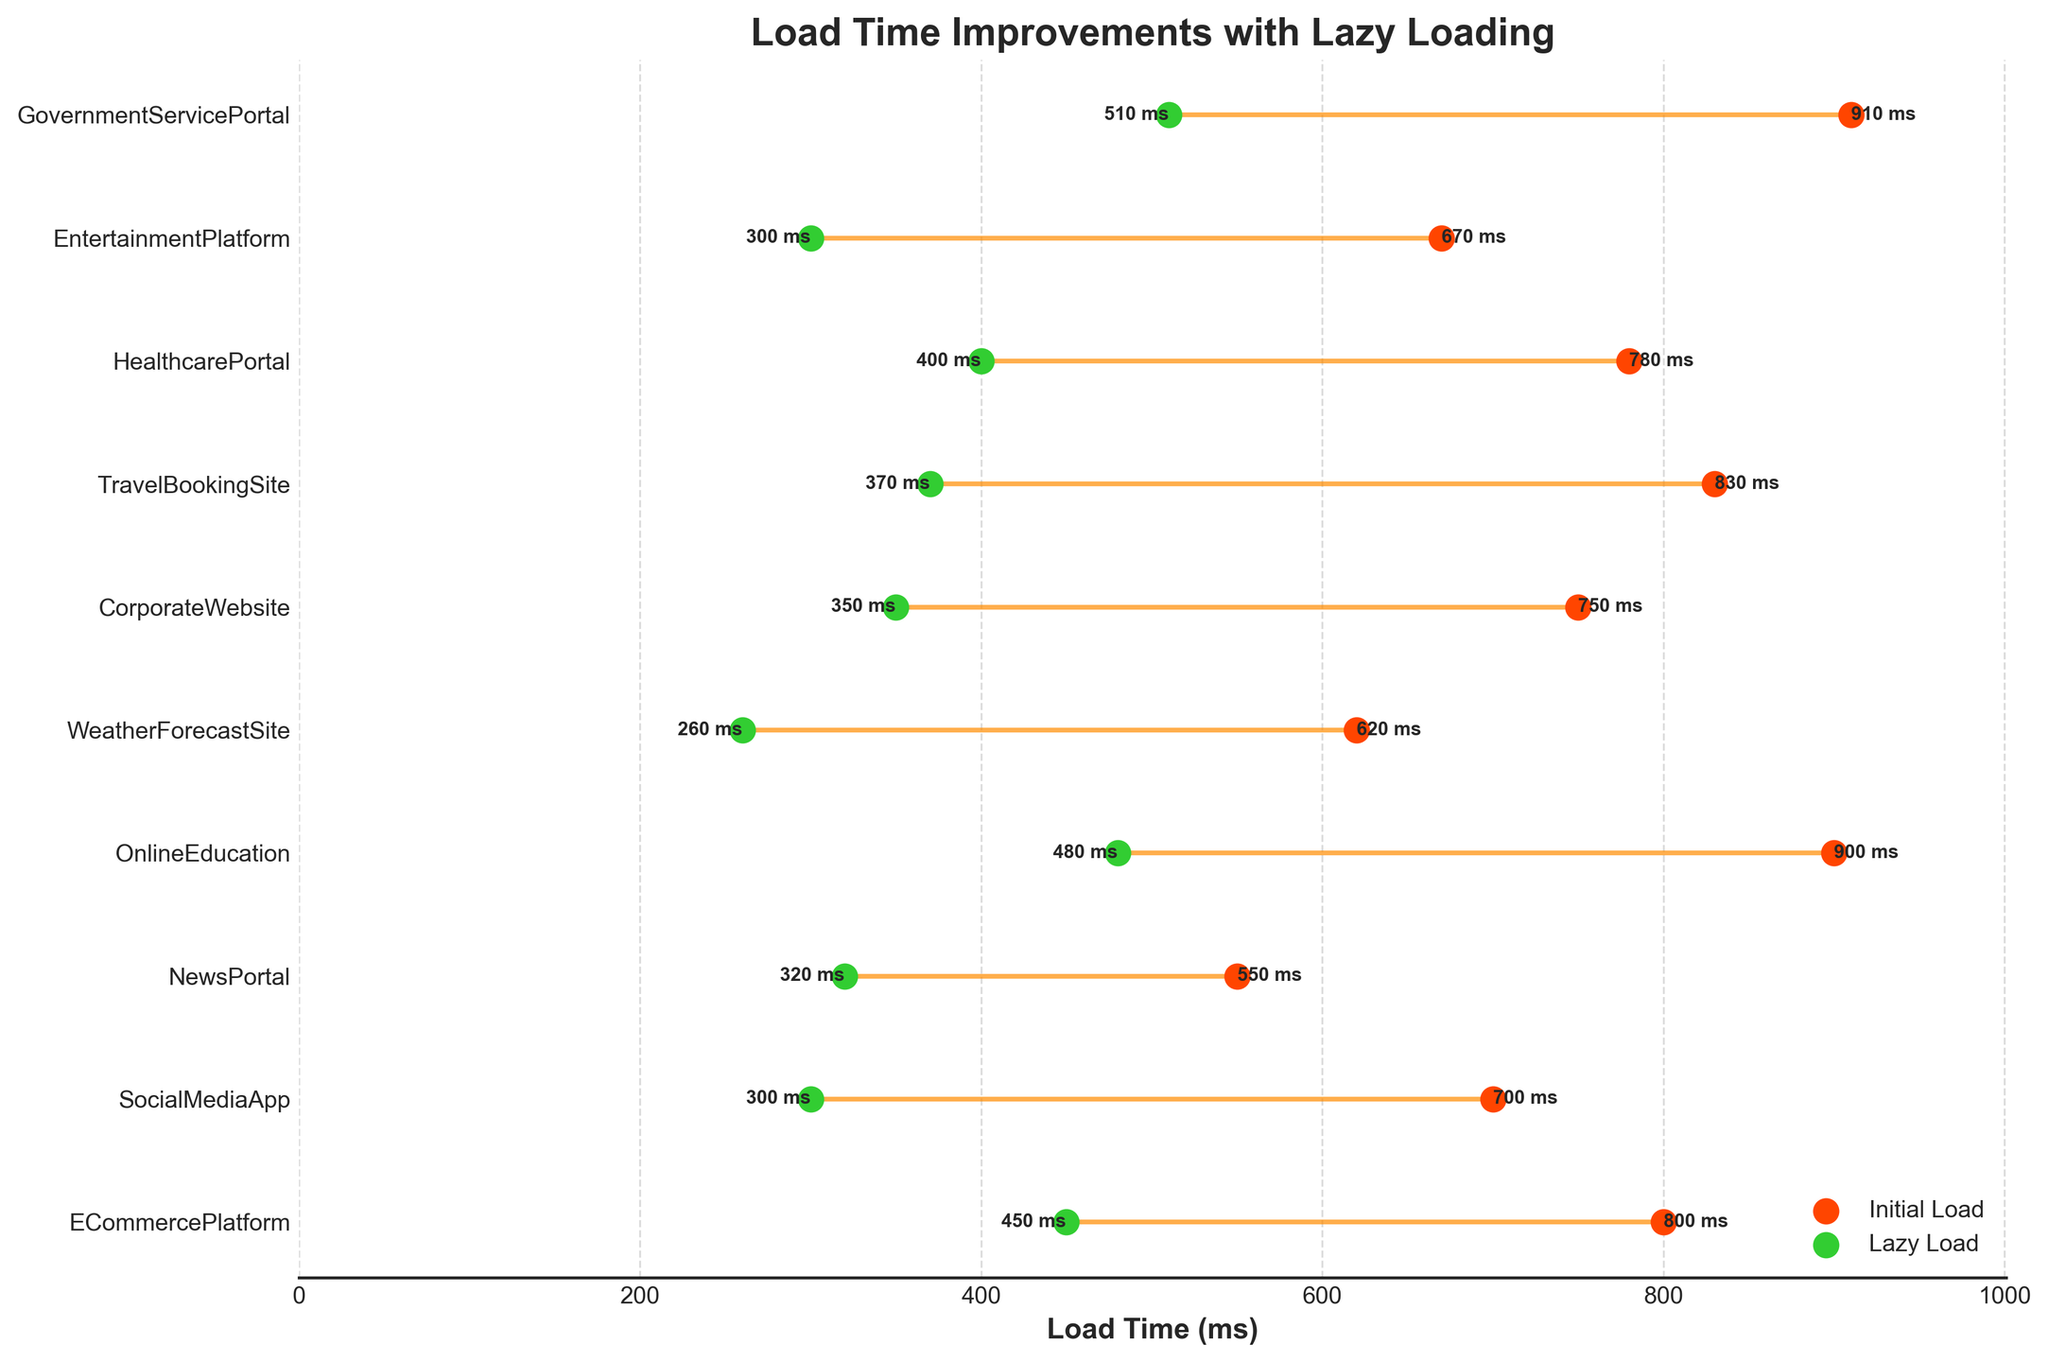What is the title of the chart? The title is displayed at the top of the chart.
Answer: Load Time Improvements with Lazy Loading How many applications are displayed in the chart? Count the number of distinct y-axis labels.
Answer: 10 Which application shows the highest initial load time? Observe the scatter plot on the x-axis and identify the maximum value for initial load time.
Answer: Government Service Portal What are the initial and lazy load times for the Social Media App? Locate the Social Media App on the y-axis and read the corresponding x-values.
Answer: 700 ms (initial), 300 ms (lazy) What is the range of load times (initial and lazy combined) for the applications? Find the minimum and maximum values on the x-axis. The range is from the lowest lazy load time to the highest initial load time.
Answer: 260 ms to 910 ms Which application shows the greatest load time reduction due to lazy loading? Calculate the difference (Initial Load - Lazy Load) for each application and identify the maximum difference.
Answer: Social Media App Which application demonstrates the smallest improvement in load time? Calculate the difference (Initial Load - Lazy Load) for each application and identify the minimum difference.
Answer: Government Service Portal What's the average load time improvement across all applications? Sum all the differences (Initial Load - Lazy Load) and divide by the number of applications.
Detailed Calculation: 
ECommercePlatform: 800 - 450 = 350 
SocialMediaApp: 700 - 300 = 400 
NewsPortal: 550 - 320 = 230 
OnlineEducation: 900 - 480 = 420 
WeatherForecastSite: 620 - 260 = 360 
CorporateWebsite: 750 - 350 = 400 
TravelBookingSite: 830 - 370 = 460 
HealthcarePortal: 780 - 400 = 380 
EntertainmentPlatform: 670 - 300 = 370 
GovernmentServicePortal: 910 - 510 = 400 
Sum of differences = 3770 
Average = 3770 / 10
Answer: 377 ms Which pair of initial and lazy load times appear the closest to each other? Identify the pair with the smallest difference.
Answer: News Portal How do the colors help differentiate the data on the chart? Describe the colors used for initial load times, lazy load times, and the connecting lines. Initial load times are shown in orange, lazy load times in green, and the lines connecting them in lighter orange.
Answer: Orange for initial load, green for lazy load, orange lines 